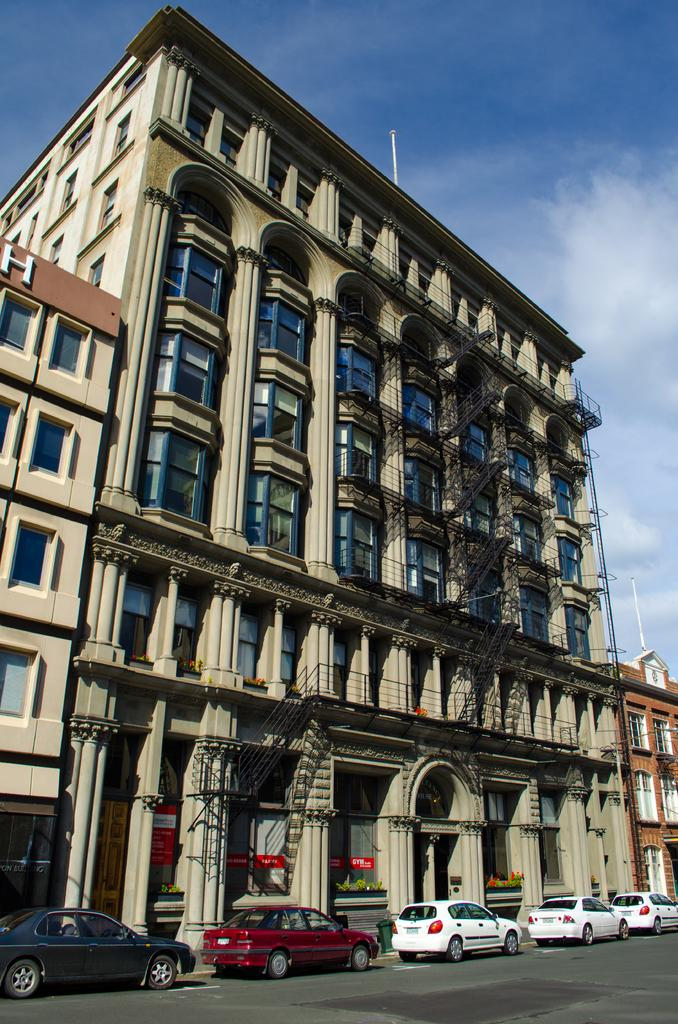What is located in the center of the image? There are buildings in the center of the image. What type of vehicles can be seen in the image? There are cars in the image. What is at the bottom of the image? There is a road at the bottom of the image. What is visible at the top of the image? The sky is visible at the top of the image. What architectural features are present in the image? There are pillars in the image. What else can be seen in the image besides buildings and cars? There are poles in the image. What type of engine is visible in the image? There is no engine visible in the image; only cars, buildings, roads, and other structures are present. How does the comb help in the image? There is no comb present in the image, so it cannot be used to help with anything. 